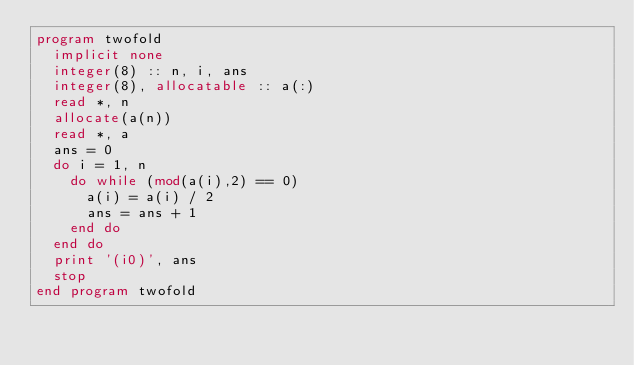<code> <loc_0><loc_0><loc_500><loc_500><_FORTRAN_>program twofold
  implicit none 
  integer(8) :: n, i, ans
  integer(8), allocatable :: a(:)
  read *, n 
  allocate(a(n)) 
  read *, a 
  ans = 0
  do i = 1, n 
    do while (mod(a(i),2) == 0)
      a(i) = a(i) / 2 
      ans = ans + 1
    end do
  end do
  print '(i0)', ans
  stop
end program twofold</code> 